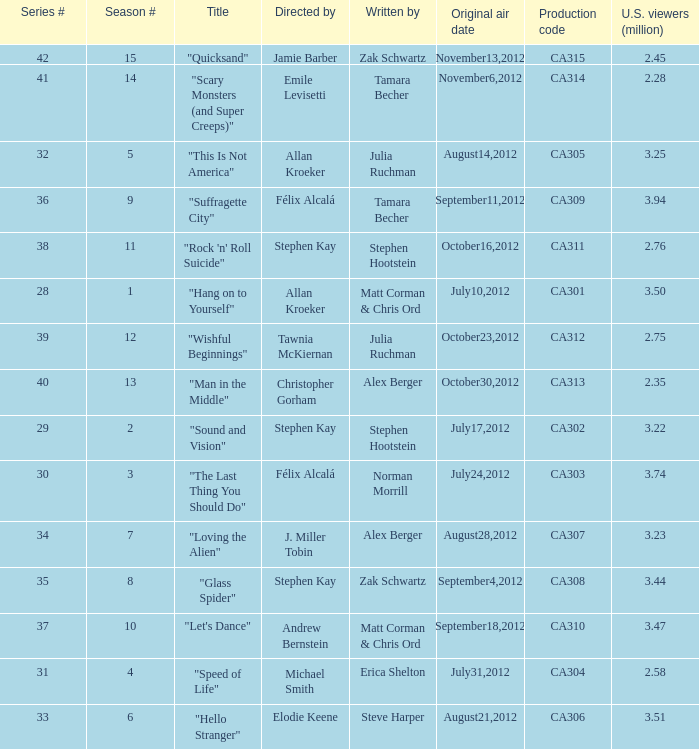Write the full table. {'header': ['Series #', 'Season #', 'Title', 'Directed by', 'Written by', 'Original air date', 'Production code', 'U.S. viewers (million)'], 'rows': [['42', '15', '"Quicksand"', 'Jamie Barber', 'Zak Schwartz', 'November13,2012', 'CA315', '2.45'], ['41', '14', '"Scary Monsters (and Super Creeps)"', 'Emile Levisetti', 'Tamara Becher', 'November6,2012', 'CA314', '2.28'], ['32', '5', '"This Is Not America"', 'Allan Kroeker', 'Julia Ruchman', 'August14,2012', 'CA305', '3.25'], ['36', '9', '"Suffragette City"', 'Félix Alcalá', 'Tamara Becher', 'September11,2012', 'CA309', '3.94'], ['38', '11', '"Rock \'n\' Roll Suicide"', 'Stephen Kay', 'Stephen Hootstein', 'October16,2012', 'CA311', '2.76'], ['28', '1', '"Hang on to Yourself"', 'Allan Kroeker', 'Matt Corman & Chris Ord', 'July10,2012', 'CA301', '3.50'], ['39', '12', '"Wishful Beginnings"', 'Tawnia McKiernan', 'Julia Ruchman', 'October23,2012', 'CA312', '2.75'], ['40', '13', '"Man in the Middle"', 'Christopher Gorham', 'Alex Berger', 'October30,2012', 'CA313', '2.35'], ['29', '2', '"Sound and Vision"', 'Stephen Kay', 'Stephen Hootstein', 'July17,2012', 'CA302', '3.22'], ['30', '3', '"The Last Thing You Should Do"', 'Félix Alcalá', 'Norman Morrill', 'July24,2012', 'CA303', '3.74'], ['34', '7', '"Loving the Alien"', 'J. Miller Tobin', 'Alex Berger', 'August28,2012', 'CA307', '3.23'], ['35', '8', '"Glass Spider"', 'Stephen Kay', 'Zak Schwartz', 'September4,2012', 'CA308', '3.44'], ['37', '10', '"Let\'s Dance"', 'Andrew Bernstein', 'Matt Corman & Chris Ord', 'September18,2012', 'CA310', '3.47'], ['31', '4', '"Speed of Life"', 'Michael Smith', 'Erica Shelton', 'July31,2012', 'CA304', '2.58'], ['33', '6', '"Hello Stranger"', 'Elodie Keene', 'Steve Harper', 'August21,2012', 'CA306', '3.51']]} What is the series episode number of the episode titled "sound and vision"? 29.0. 